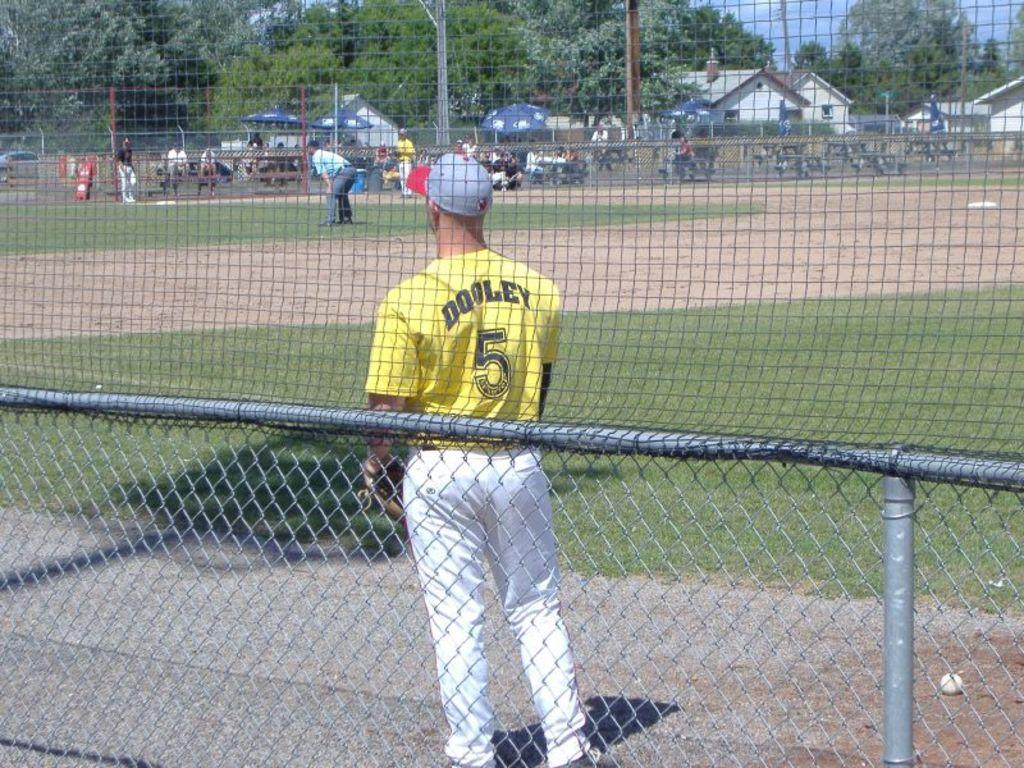<image>
Create a compact narrative representing the image presented. Dooley is number 5 on this baseball team, and he's wearing white pants. 